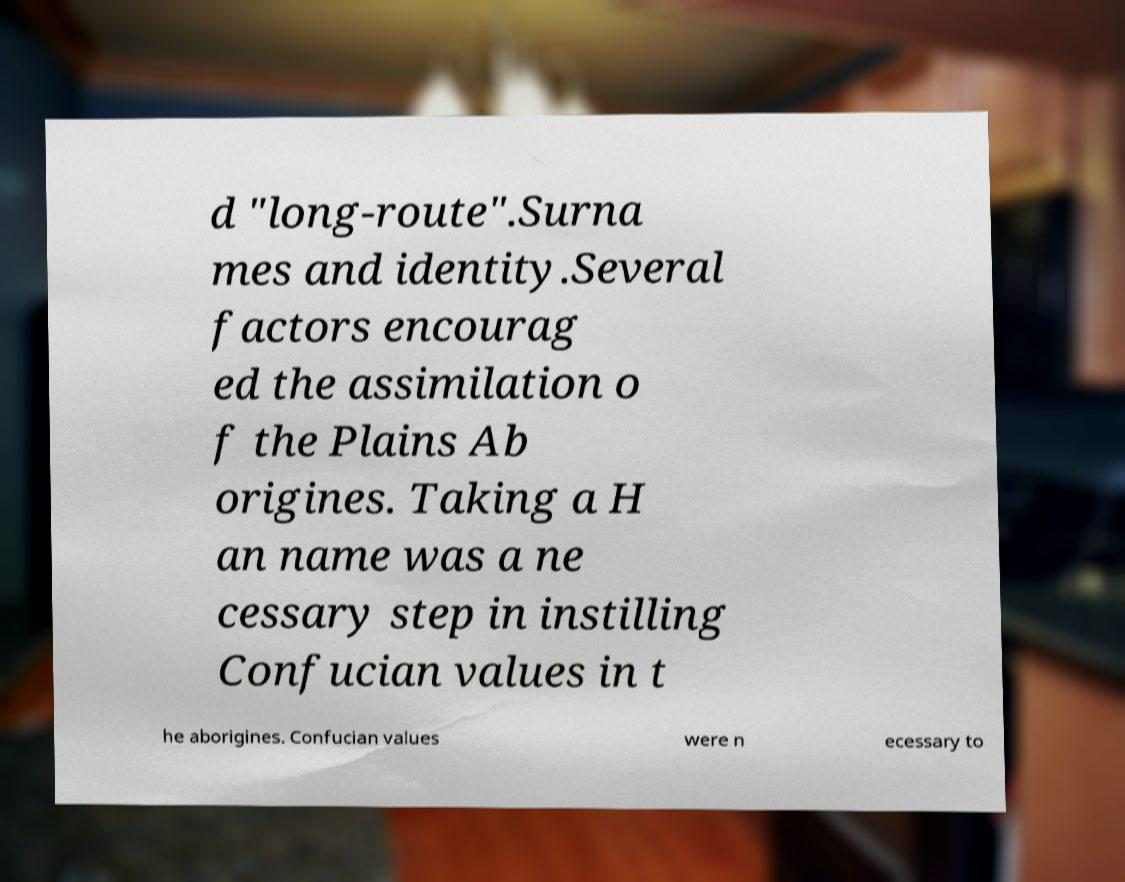I need the written content from this picture converted into text. Can you do that? d "long-route".Surna mes and identity.Several factors encourag ed the assimilation o f the Plains Ab origines. Taking a H an name was a ne cessary step in instilling Confucian values in t he aborigines. Confucian values were n ecessary to 